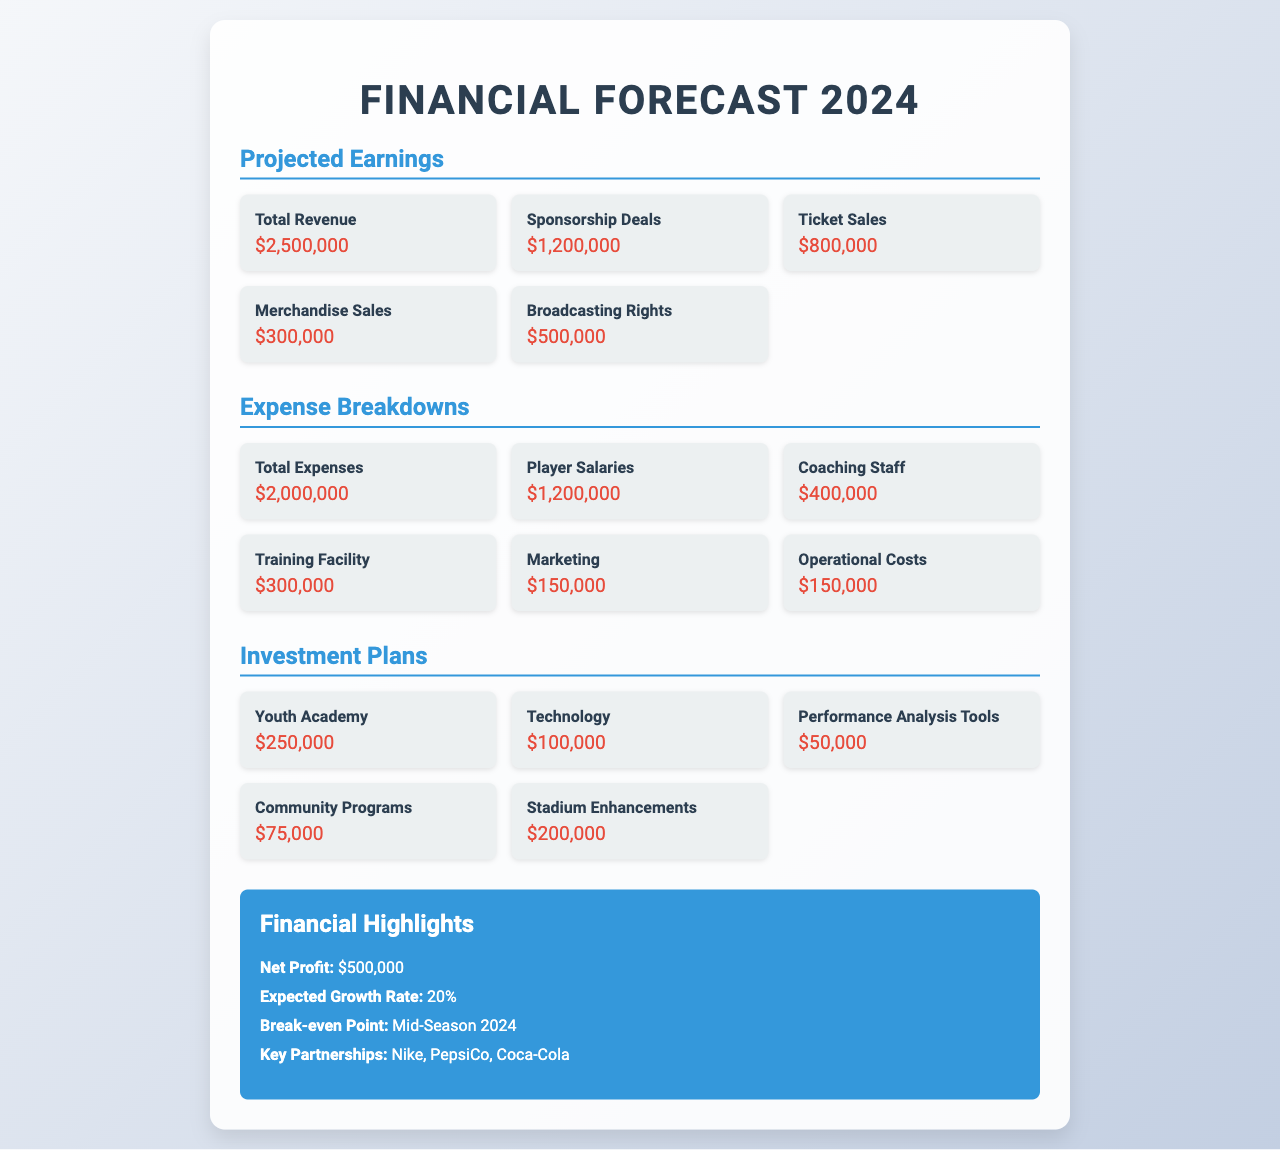What is the total revenue? The total revenue is listed under the Projected Earnings section, which sums all revenue sources to $2,500,000.
Answer: $2,500,000 What is the largest expense? The largest expense in the Expense Breakdowns section is Player Salaries, amounting to $1,200,000.
Answer: $1,200,000 What is the budget for the Youth Academy investment? The budget for the Youth Academy investment is specified in the Investment Plans section, which lists it as $250,000.
Answer: $250,000 What is the net profit? The net profit is detailed in the Financial Highlights section, stating it is $500,000.
Answer: $500,000 What is the expected growth rate? The expected growth rate can be found in the Financial Highlights section, which indicates it is 20%.
Answer: 20% Which company is a key partnership mentioned? A key partnership mentioned in the Financial Highlights section is Nike.
Answer: Nike What is the total expenses? The total expenses listed under the Expense Breakdowns section amount to $2,000,000.
Answer: $2,000,000 What is the budget for Stadium Enhancements? The budget for Stadium Enhancements is specified under Investment Plans, which is $200,000.
Answer: $200,000 When is the break-even point expected? The expected break-even point is indicated in the Financial Highlights section as Mid-Season 2024.
Answer: Mid-Season 2024 